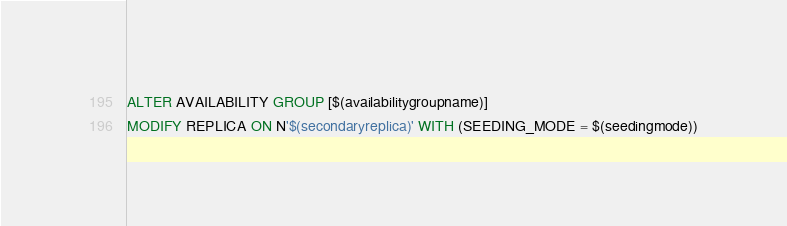<code> <loc_0><loc_0><loc_500><loc_500><_SQL_>ALTER AVAILABILITY GROUP [$(availabilitygroupname)]
MODIFY REPLICA ON N'$(secondaryreplica)' WITH (SEEDING_MODE = $(seedingmode))
</code> 